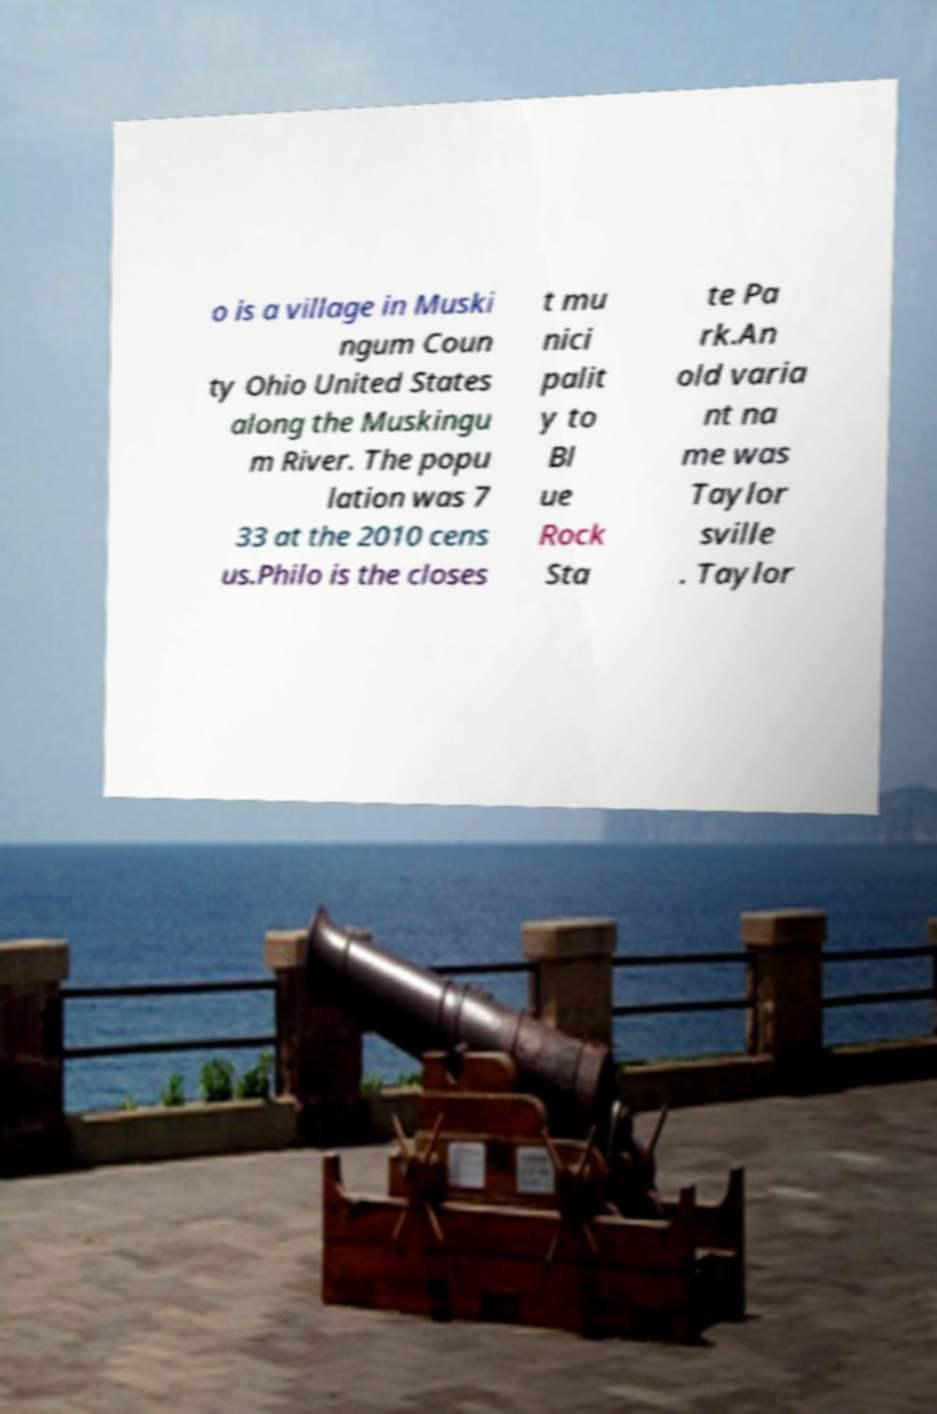Please read and relay the text visible in this image. What does it say? o is a village in Muski ngum Coun ty Ohio United States along the Muskingu m River. The popu lation was 7 33 at the 2010 cens us.Philo is the closes t mu nici palit y to Bl ue Rock Sta te Pa rk.An old varia nt na me was Taylor sville . Taylor 